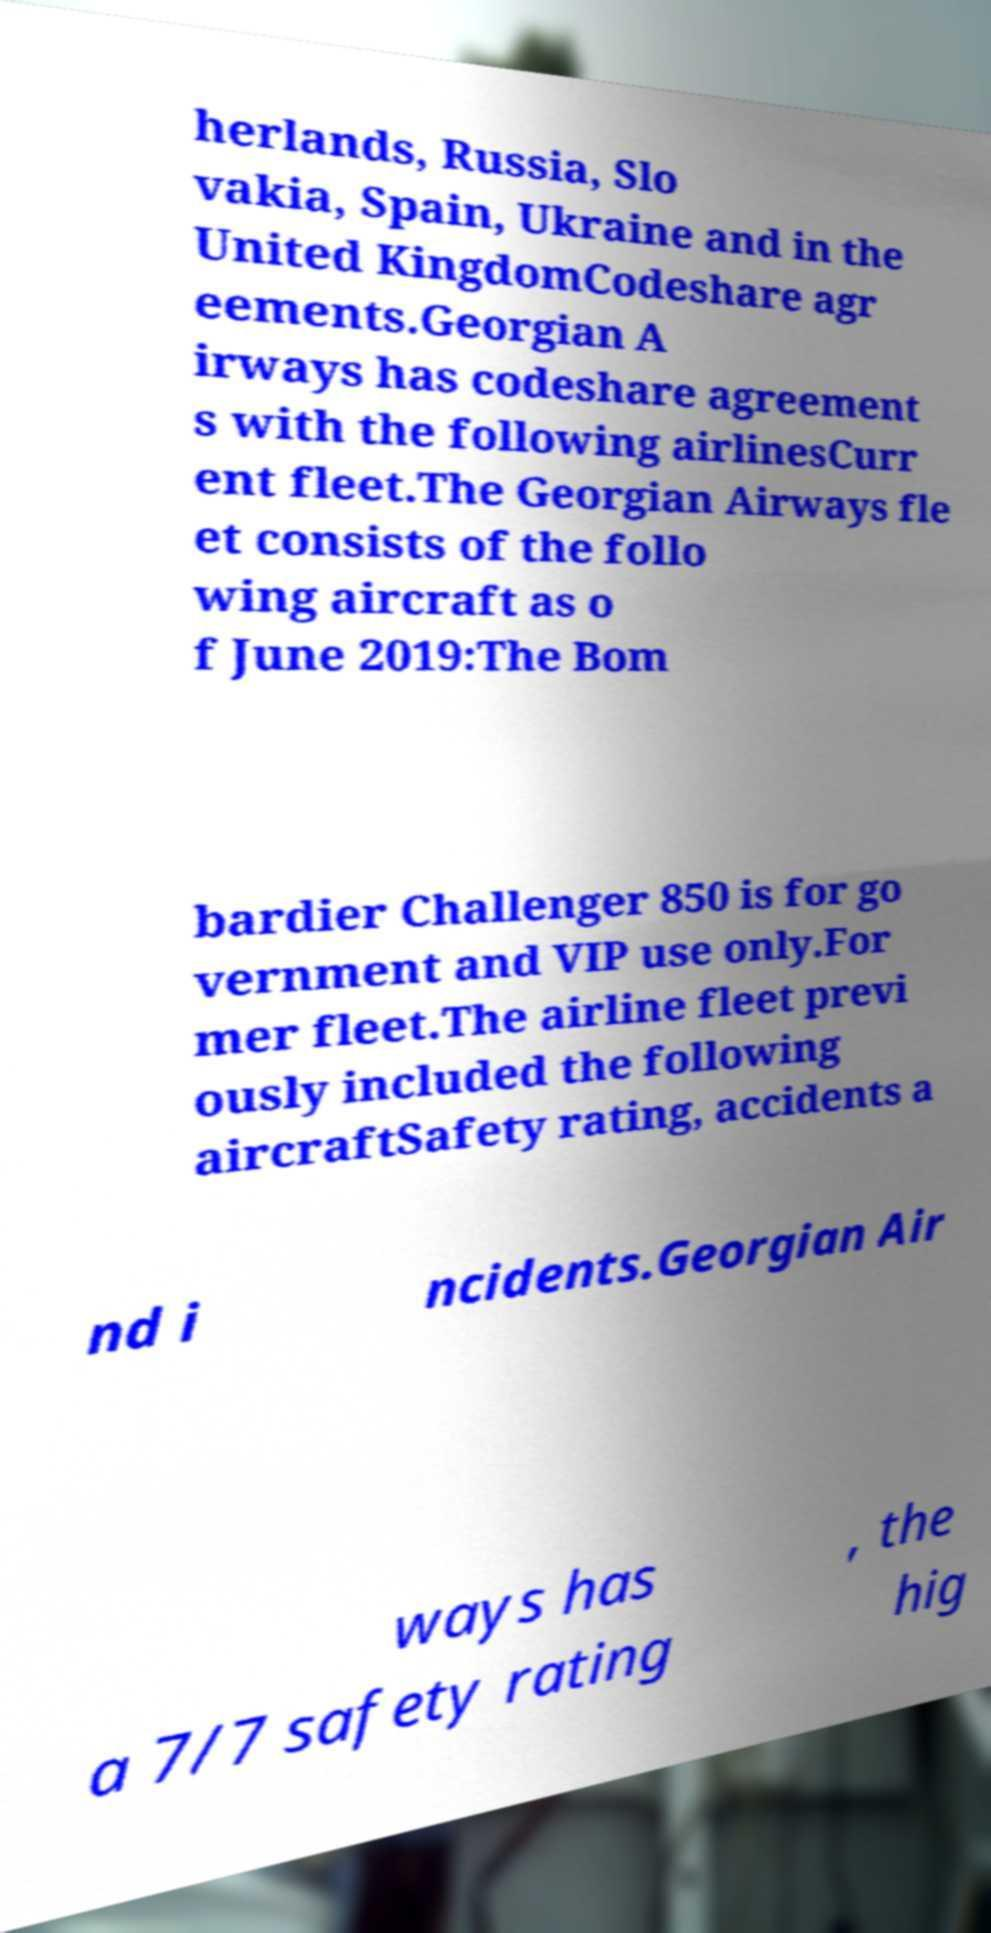Please identify and transcribe the text found in this image. herlands, Russia, Slo vakia, Spain, Ukraine and in the United KingdomCodeshare agr eements.Georgian A irways has codeshare agreement s with the following airlinesCurr ent fleet.The Georgian Airways fle et consists of the follo wing aircraft as o f June 2019:The Bom bardier Challenger 850 is for go vernment and VIP use only.For mer fleet.The airline fleet previ ously included the following aircraftSafety rating, accidents a nd i ncidents.Georgian Air ways has a 7/7 safety rating , the hig 